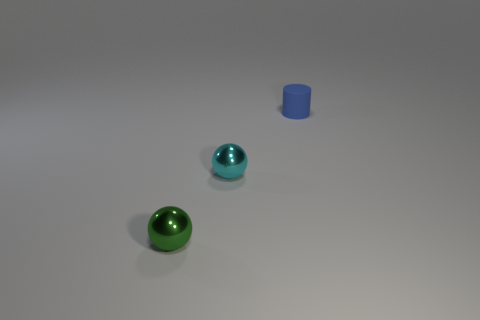Subtract all cylinders. How many objects are left? 2 Subtract all brown spheres. Subtract all purple cylinders. How many spheres are left? 2 Subtract all brown blocks. How many green balls are left? 1 Subtract all cyan objects. Subtract all blue cylinders. How many objects are left? 1 Add 2 tiny blue things. How many tiny blue things are left? 3 Add 2 big metallic spheres. How many big metallic spheres exist? 2 Add 1 cyan metal spheres. How many objects exist? 4 Subtract 0 green cylinders. How many objects are left? 3 Subtract 1 cylinders. How many cylinders are left? 0 